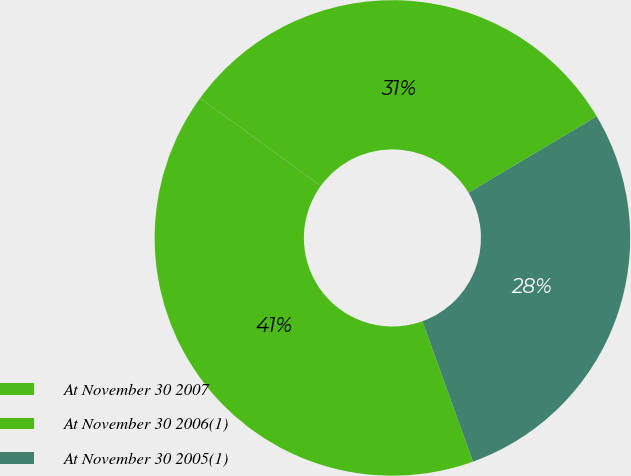Convert chart to OTSL. <chart><loc_0><loc_0><loc_500><loc_500><pie_chart><fcel>At November 30 2007<fcel>At November 30 2006(1)<fcel>At November 30 2005(1)<nl><fcel>31.45%<fcel>40.51%<fcel>28.04%<nl></chart> 